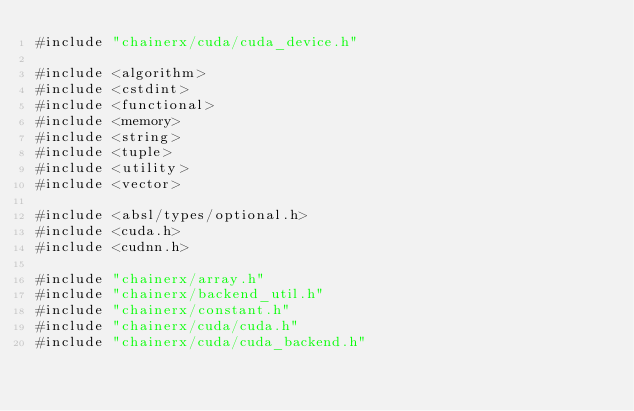Convert code to text. <code><loc_0><loc_0><loc_500><loc_500><_Cuda_>#include "chainerx/cuda/cuda_device.h"

#include <algorithm>
#include <cstdint>
#include <functional>
#include <memory>
#include <string>
#include <tuple>
#include <utility>
#include <vector>

#include <absl/types/optional.h>
#include <cuda.h>
#include <cudnn.h>

#include "chainerx/array.h"
#include "chainerx/backend_util.h"
#include "chainerx/constant.h"
#include "chainerx/cuda/cuda.h"
#include "chainerx/cuda/cuda_backend.h"</code> 